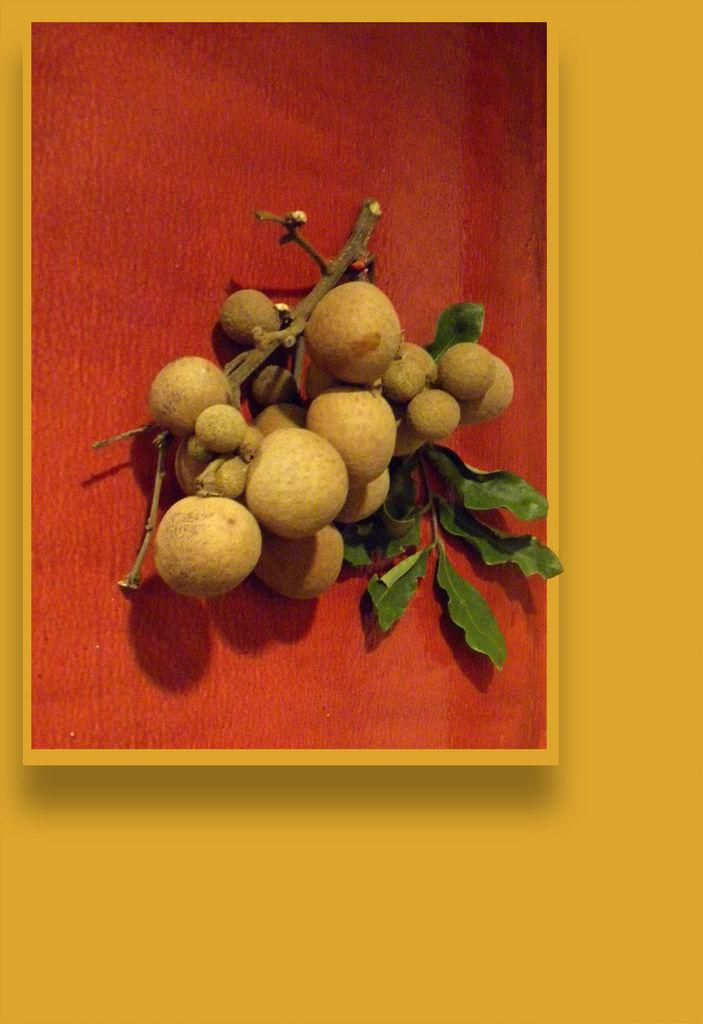What type of food items can be seen in the image? There are fruits in the image. What else is present in the image besides the fruits? There are leaves in the image. What color is the prominent surface in the image? The red surface is present in the image. What can be seen in the background of the image? The background of the image includes a yellow surface. What type of medical advice does the doctor give in the image? There is no doctor present in the image, so it is not possible to answer that question. 